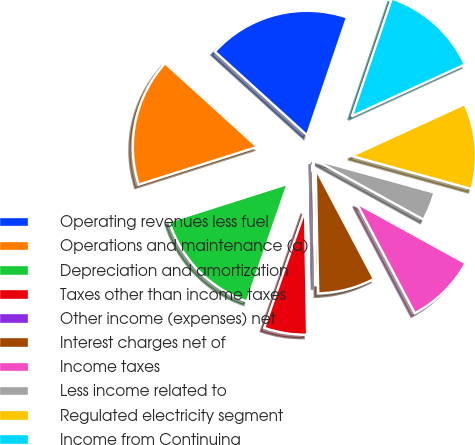<chart> <loc_0><loc_0><loc_500><loc_500><pie_chart><fcel>Operating revenues less fuel<fcel>Operations and maintenance (a)<fcel>Depreciation and amortization<fcel>Taxes other than income taxes<fcel>Other income (expenses) net<fcel>Interest charges net of<fcel>Income taxes<fcel>Less income related to<fcel>Regulated electricity segment<fcel>Income from Continuing<nl><fcel>18.48%<fcel>16.63%<fcel>14.79%<fcel>5.58%<fcel>0.05%<fcel>7.42%<fcel>9.26%<fcel>3.73%<fcel>11.11%<fcel>12.95%<nl></chart> 